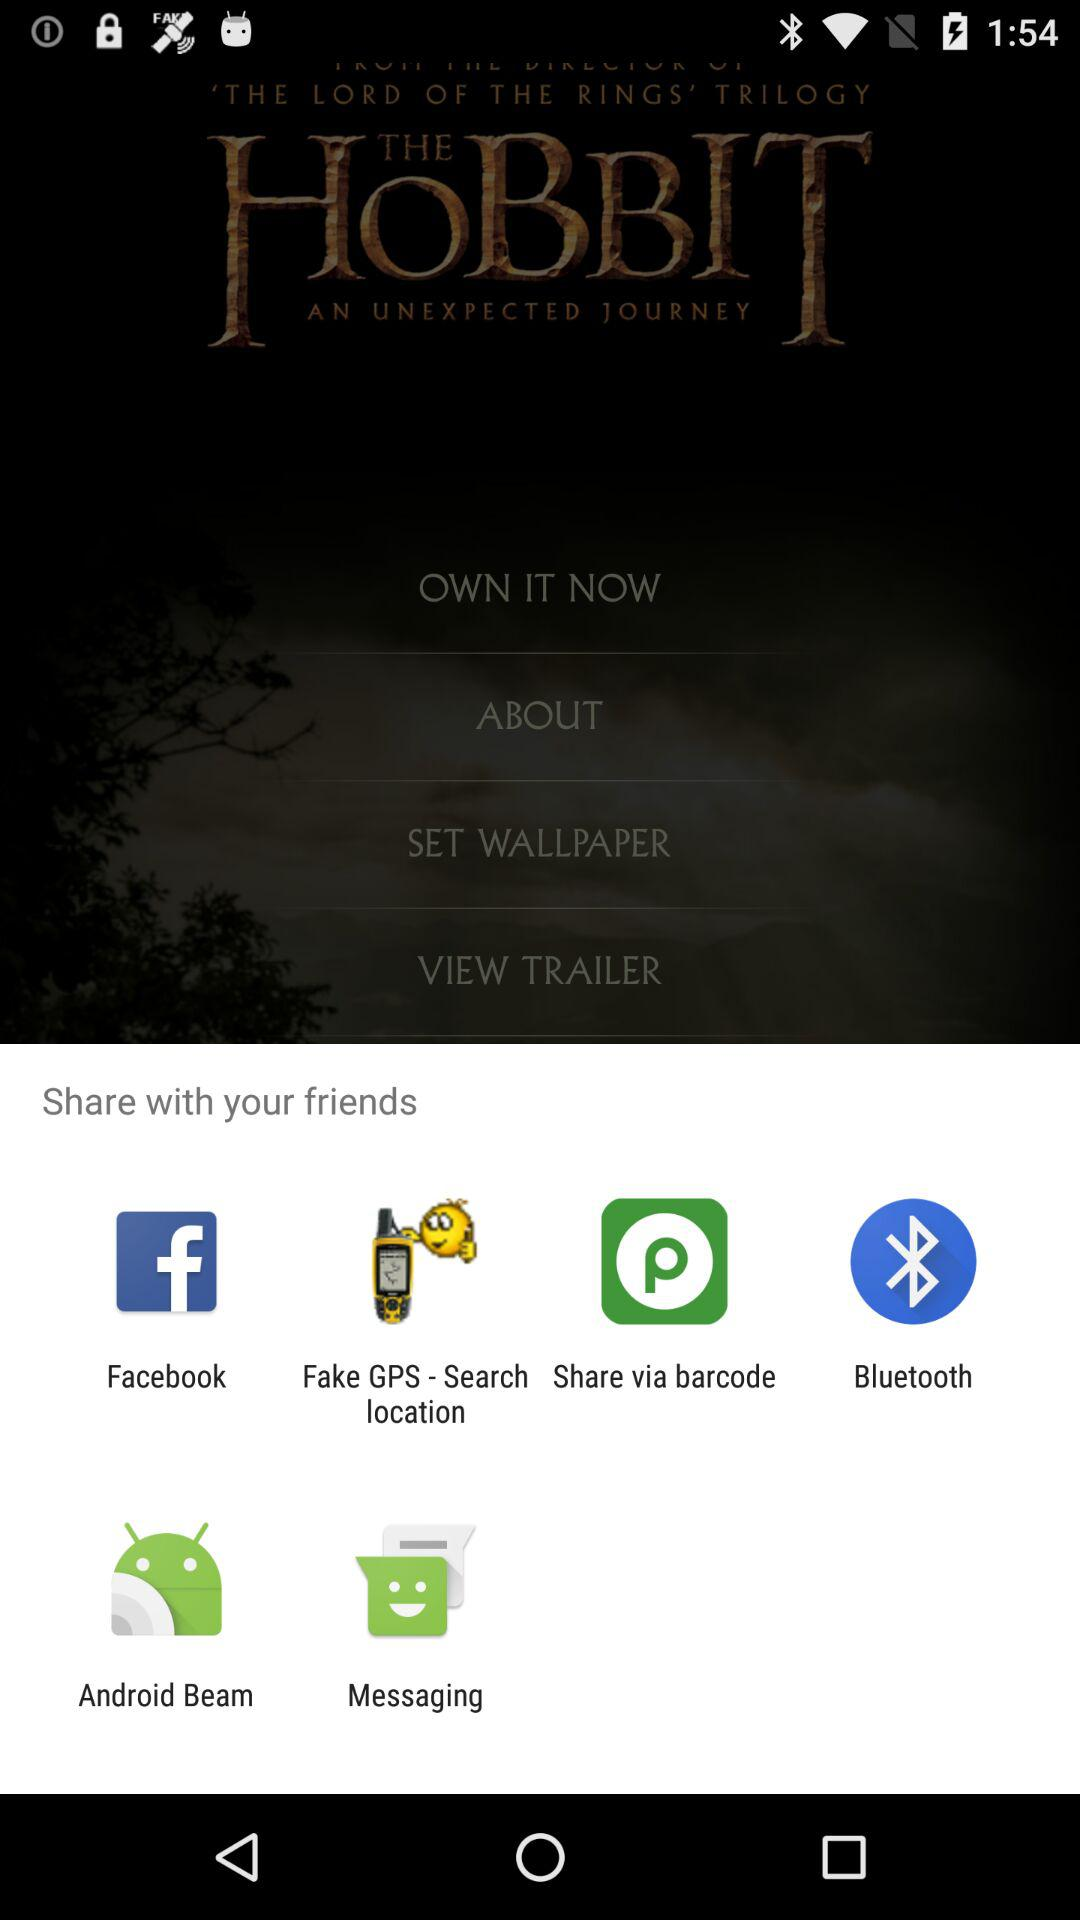What are the alternatives for sharing? The alternatives for sharing are "Facebook", "Fake GPS - Search location", "Share via barcode", "Bluetooth", "Android Beam" and "Messaging". 